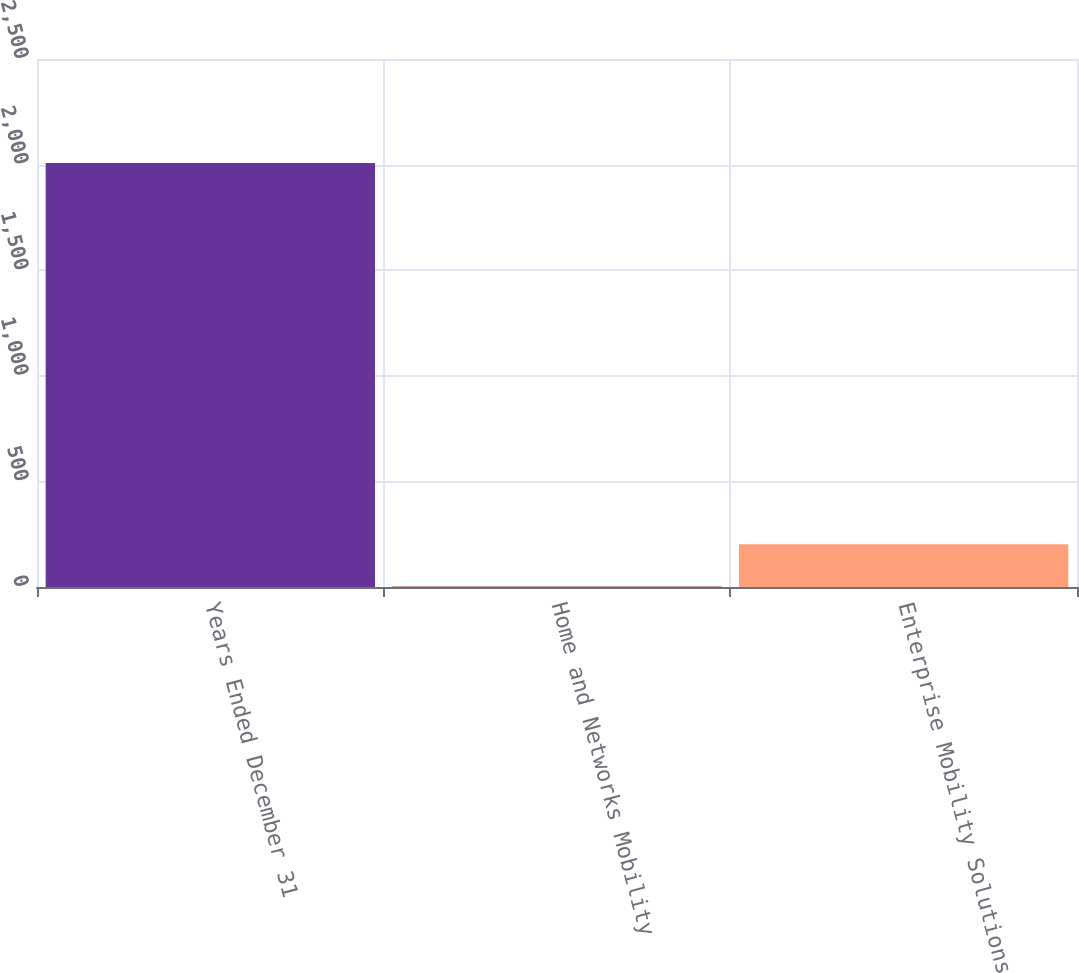Convert chart. <chart><loc_0><loc_0><loc_500><loc_500><bar_chart><fcel>Years Ended December 31<fcel>Home and Networks Mobility<fcel>Enterprise Mobility Solutions<nl><fcel>2008<fcel>2<fcel>202.6<nl></chart> 